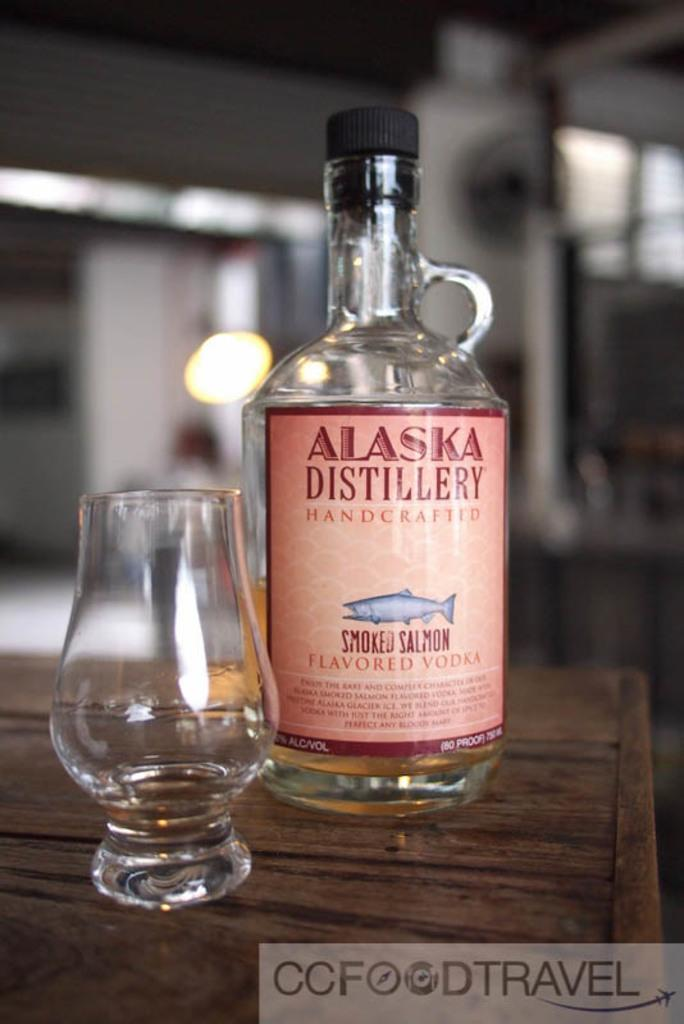<image>
Offer a succinct explanation of the picture presented. a bottle of Alaska Distillery smoked salmon flavored vodka next to a glass 